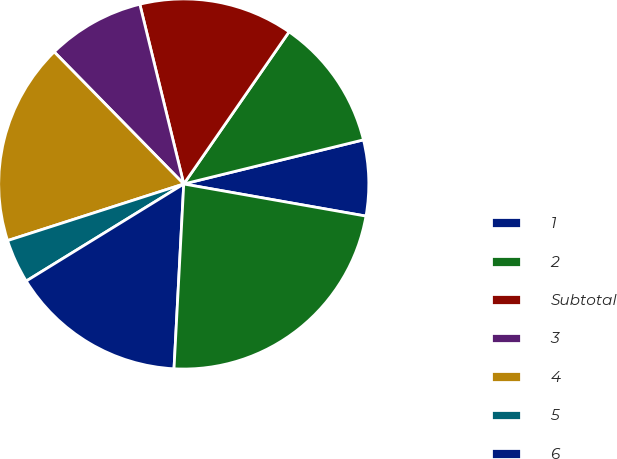Convert chart. <chart><loc_0><loc_0><loc_500><loc_500><pie_chart><fcel>1<fcel>2<fcel>Subtotal<fcel>3<fcel>4<fcel>5<fcel>6<fcel>Total(2)<nl><fcel>6.61%<fcel>11.53%<fcel>13.45%<fcel>8.53%<fcel>17.6%<fcel>3.84%<fcel>15.37%<fcel>23.06%<nl></chart> 